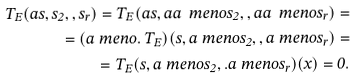Convert formula to latex. <formula><loc_0><loc_0><loc_500><loc_500>T _ { E } ( a s , s _ { 2 } , , s _ { r } ) = T _ { E } ( a s , a a \ m e n o s _ { 2 } , , a a \ m e n o s _ { r } ) = \\ = ( a \ m e n o . \, T _ { E } ) ( s , a \ m e n o s _ { 2 } , , a \ m e n o s _ { r } ) = \\ = T _ { E } ( s , a \ m e n o s _ { 2 } , . a \ m e n o s _ { r } ) ( x ) = 0 .</formula> 